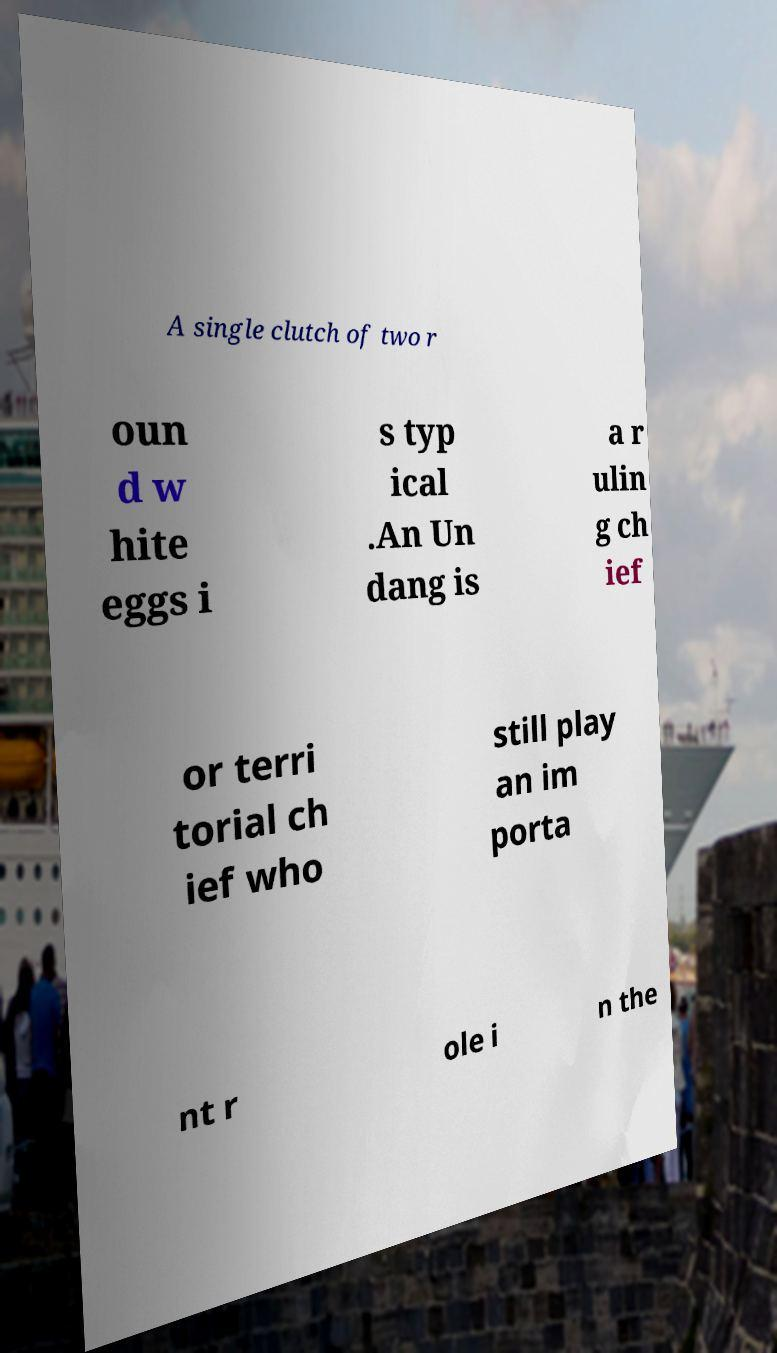For documentation purposes, I need the text within this image transcribed. Could you provide that? A single clutch of two r oun d w hite eggs i s typ ical .An Un dang is a r ulin g ch ief or terri torial ch ief who still play an im porta nt r ole i n the 